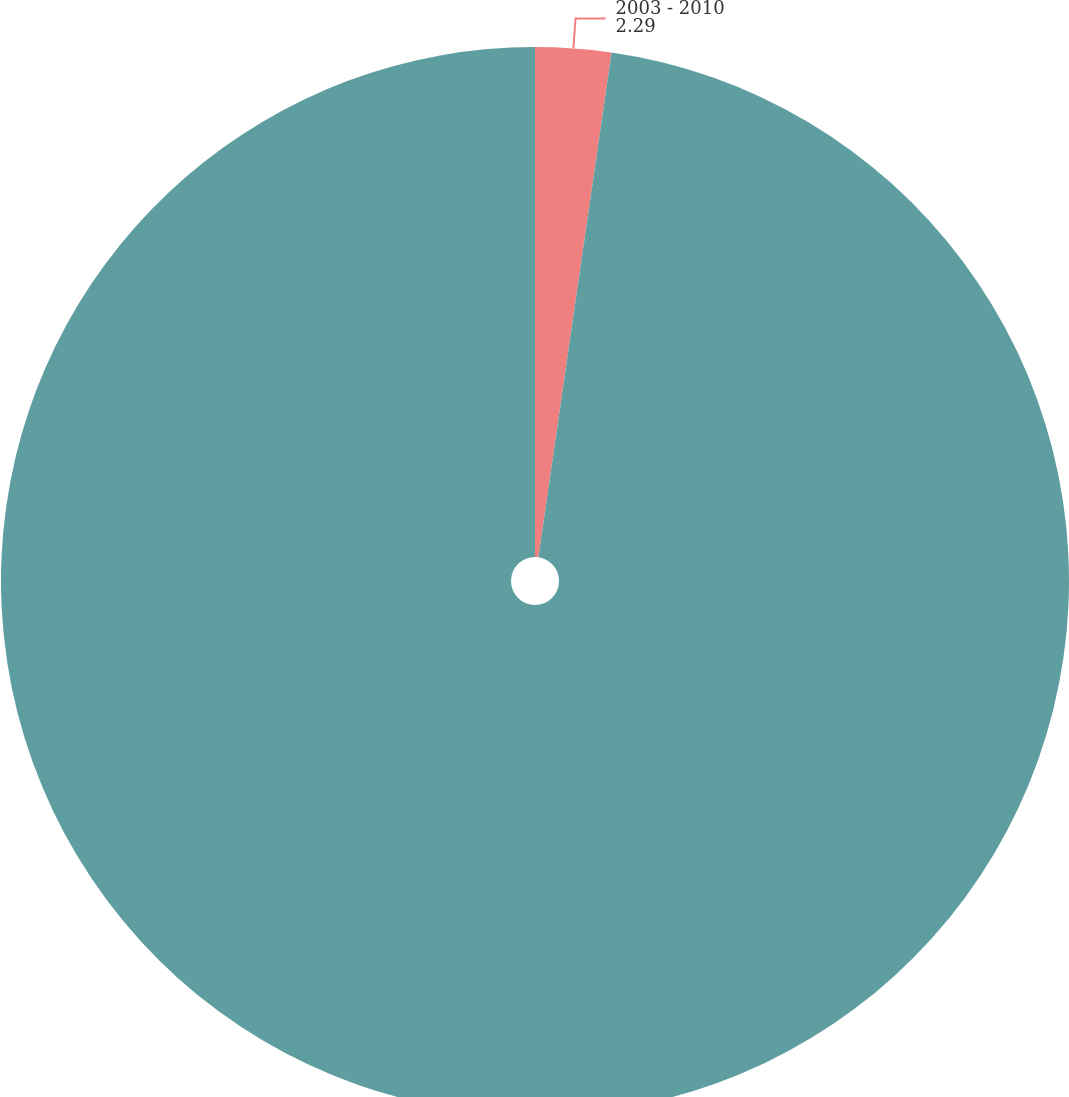Convert chart to OTSL. <chart><loc_0><loc_0><loc_500><loc_500><pie_chart><fcel>2003 - 2010<fcel>Total<nl><fcel>2.29%<fcel>97.71%<nl></chart> 